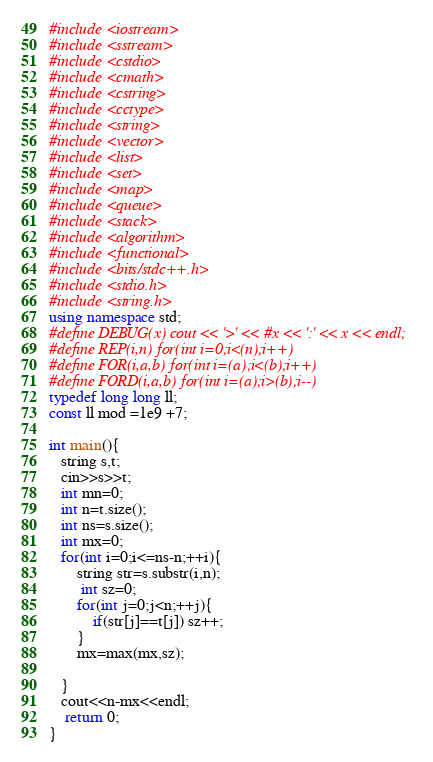<code> <loc_0><loc_0><loc_500><loc_500><_C++_>#include <iostream>
#include <sstream>
#include <cstdio>
#include <cmath>
#include <cstring>
#include <cctype>
#include <string>
#include <vector>
#include <list>
#include <set>
#include <map>
#include <queue>
#include <stack>
#include <algorithm>
#include <functional>
#include <bits/stdc++.h>
#include <stdio.h>
#include <string.h>
using namespace std;
#define DEBUG(x) cout << '>' << #x << ':' << x << endl;
#define REP(i,n) for(int i=0;i<(n);i++)
#define FOR(i,a,b) for(int i=(a);i<(b);i++)
#define FORD(i,a,b) for(int i=(a);i>(b);i--)
typedef long long ll;
const ll mod =1e9 +7;

int main(){
   string s,t;
   cin>>s>>t;
   int mn=0;
   int n=t.size();
   int ns=s.size();
   int mx=0;
   for(int i=0;i<=ns-n;++i){
       string str=s.substr(i,n);
        int sz=0;
       for(int j=0;j<n;++j){
           if(str[j]==t[j]) sz++;
       }
       mx=max(mx,sz);

   }
   cout<<n-mx<<endl;
    return 0;
}</code> 